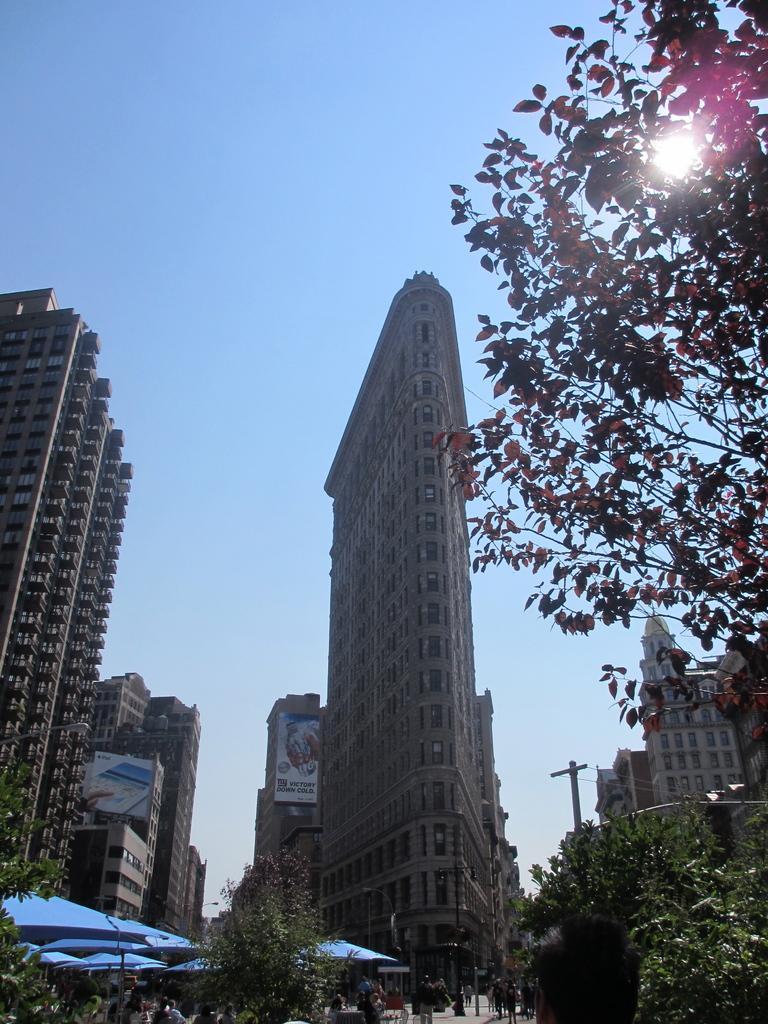Could you give a brief overview of what you see in this image? In this image there are tall buildings. There are trees. There is a sky. 